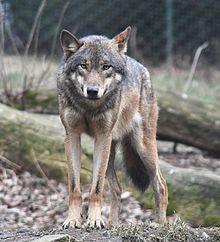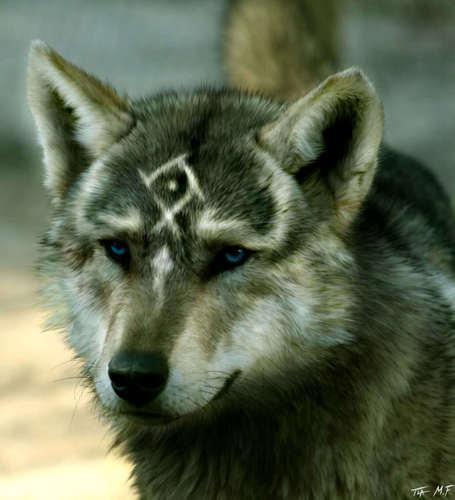The first image is the image on the left, the second image is the image on the right. For the images displayed, is the sentence "There is one wolf per image, and none of the wolves are showing their teeth." factually correct? Answer yes or no. Yes. 